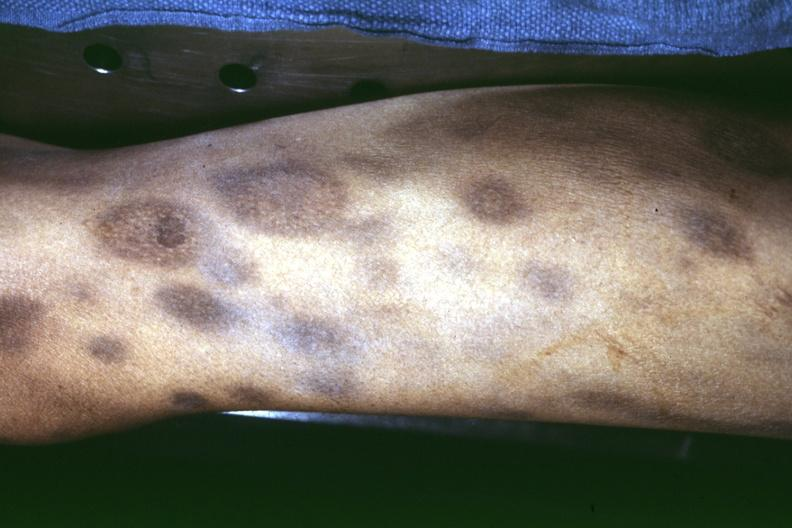what ecchymoses with necrotizing centers?
Answer the question using a single word or phrase. Thigh at autopsy 